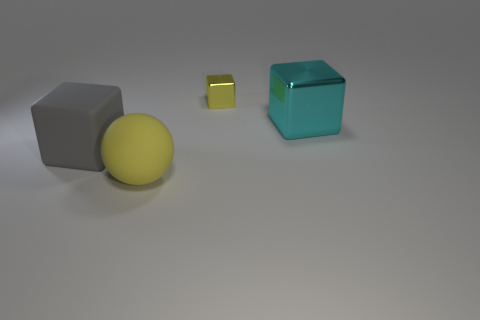What size is the sphere that is the same color as the tiny shiny block?
Keep it short and to the point. Large. What size is the yellow object that is the same shape as the big gray matte object?
Your response must be concise. Small. Are there any other things that have the same size as the yellow metallic cube?
Your answer should be very brief. No. There is a cyan thing; does it have the same size as the rubber object right of the big gray rubber thing?
Provide a short and direct response. Yes. There is a big rubber thing on the left side of the yellow ball; what is its shape?
Provide a succinct answer. Cube. What color is the large thing that is to the right of the yellow object in front of the large shiny thing?
Ensure brevity in your answer.  Cyan. What color is the rubber thing that is the same shape as the small yellow shiny object?
Provide a succinct answer. Gray. What number of tiny things are the same color as the big metal cube?
Your answer should be compact. 0. Does the rubber ball have the same color as the object behind the big cyan block?
Give a very brief answer. Yes. There is a object that is both left of the cyan block and to the right of the big yellow thing; what is its shape?
Keep it short and to the point. Cube. 